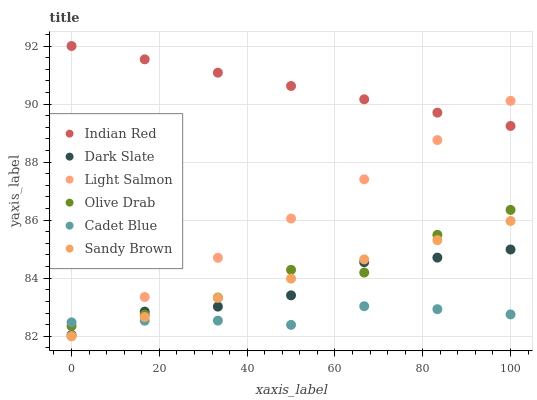Does Cadet Blue have the minimum area under the curve?
Answer yes or no. Yes. Does Indian Red have the maximum area under the curve?
Answer yes or no. Yes. Does Dark Slate have the minimum area under the curve?
Answer yes or no. No. Does Dark Slate have the maximum area under the curve?
Answer yes or no. No. Is Sandy Brown the smoothest?
Answer yes or no. Yes. Is Olive Drab the roughest?
Answer yes or no. Yes. Is Cadet Blue the smoothest?
Answer yes or no. No. Is Cadet Blue the roughest?
Answer yes or no. No. Does Light Salmon have the lowest value?
Answer yes or no. Yes. Does Cadet Blue have the lowest value?
Answer yes or no. No. Does Indian Red have the highest value?
Answer yes or no. Yes. Does Dark Slate have the highest value?
Answer yes or no. No. Is Cadet Blue less than Indian Red?
Answer yes or no. Yes. Is Indian Red greater than Sandy Brown?
Answer yes or no. Yes. Does Dark Slate intersect Olive Drab?
Answer yes or no. Yes. Is Dark Slate less than Olive Drab?
Answer yes or no. No. Is Dark Slate greater than Olive Drab?
Answer yes or no. No. Does Cadet Blue intersect Indian Red?
Answer yes or no. No. 